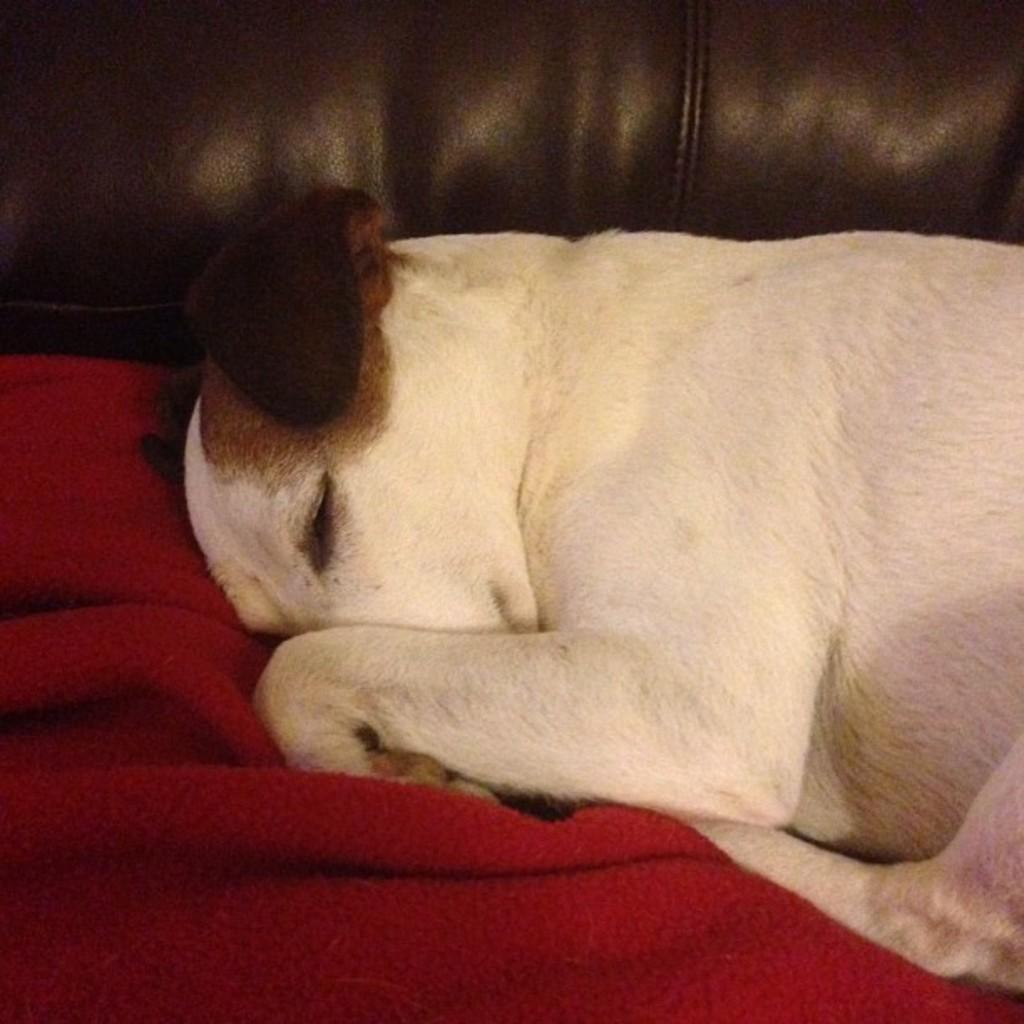Can you describe this image briefly? In this image there is a dog sleeping on the sofa and there is a towel in red color. 